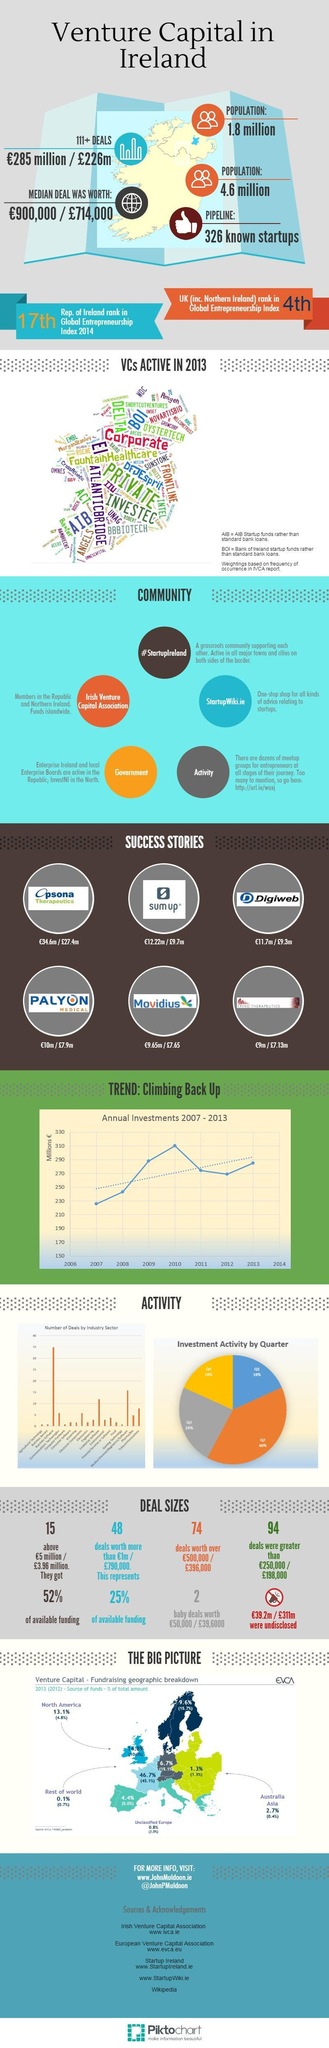What percentage of total amount is funded by Venture Capital in Australia in 2013?
Answer the question with a short phrase. 2.7% How many deals made by the Venture Capital were greater than €250,000 / €396,000? 94 What percentage of total amount is funded by Venture Capital in North America in 2012? (4.8%) How many deals made by the Venture Capital are worth over €500,000 / €396,000? 74 